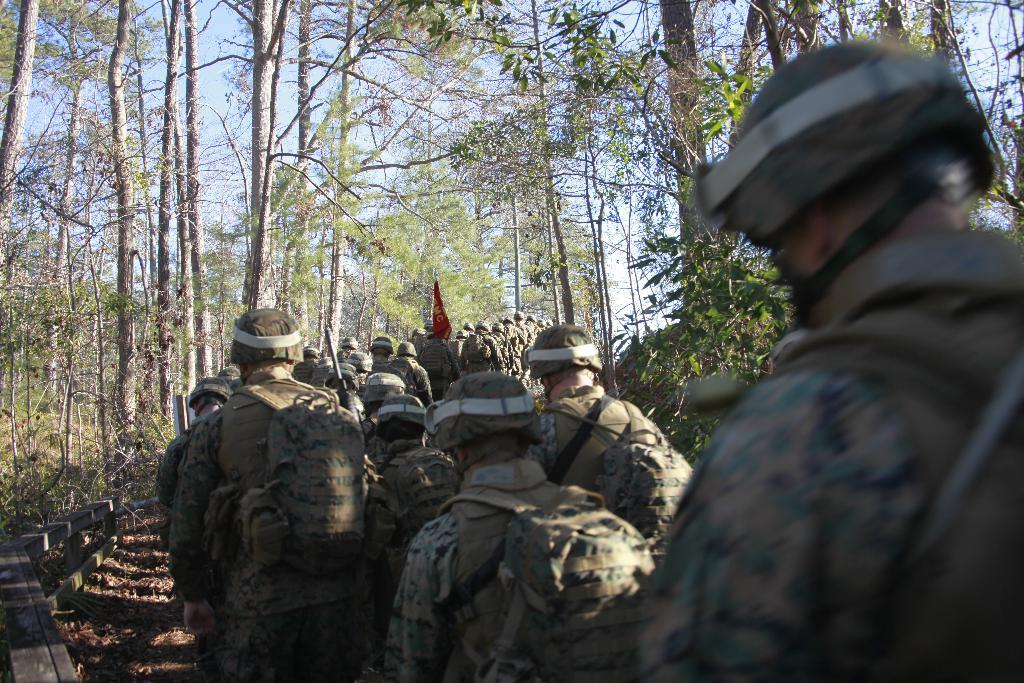What can be seen in the image? There are men in the image. What are the men doing? The men are walking on the ground. What are the men carrying on their backs? The men are wearing backpacks. What can be seen in the background of the image? There are trees, sky, and a wooden fence visible in the background. What type of balls are being used to cover the men while they sleep in the image? There are no balls or sleeping men present in the image; the men are walking with backpacks. 